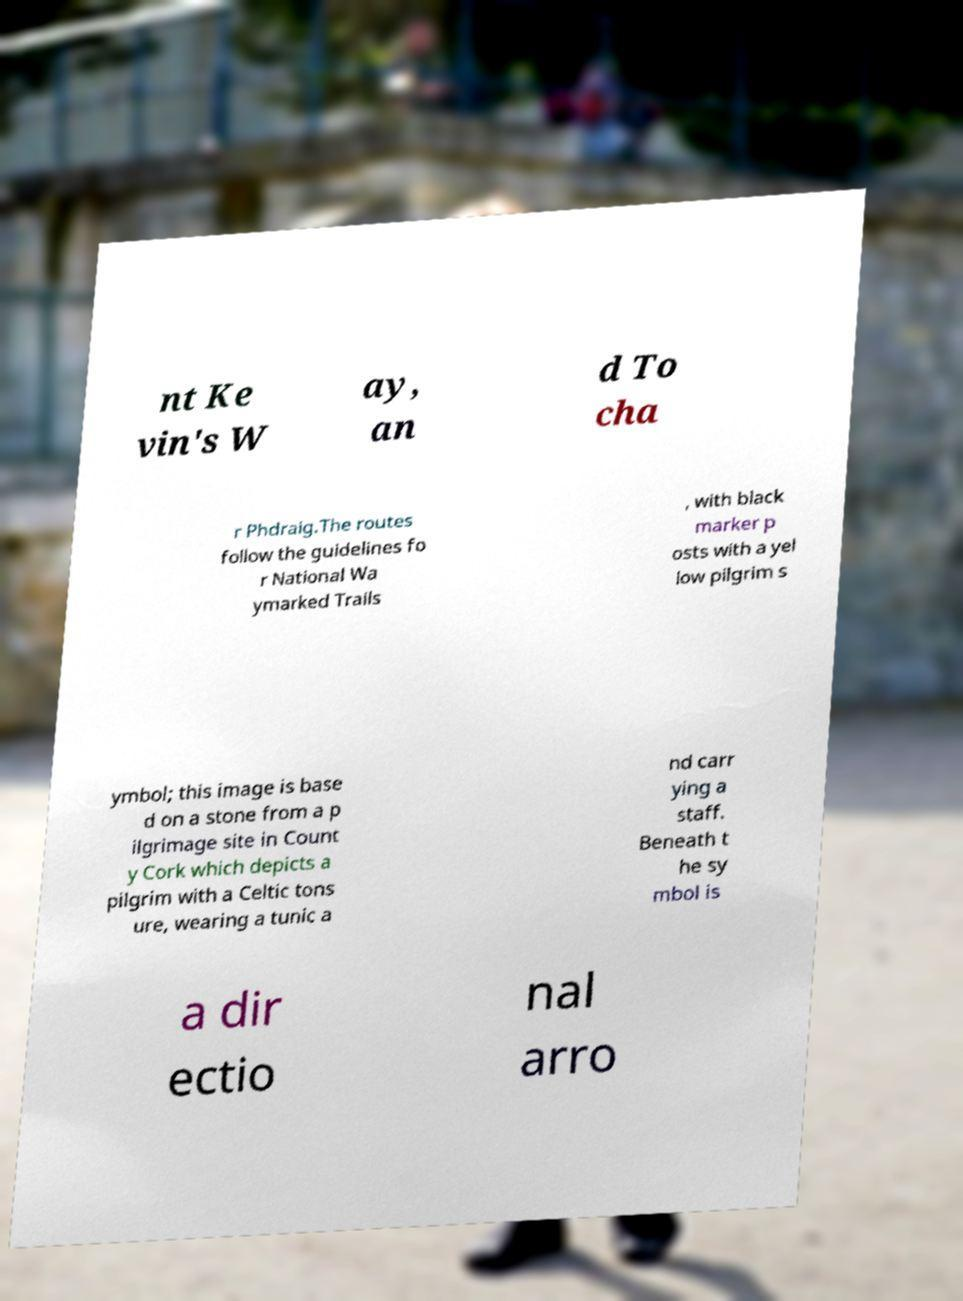For documentation purposes, I need the text within this image transcribed. Could you provide that? nt Ke vin's W ay, an d To cha r Phdraig.The routes follow the guidelines fo r National Wa ymarked Trails , with black marker p osts with a yel low pilgrim s ymbol; this image is base d on a stone from a p ilgrimage site in Count y Cork which depicts a pilgrim with a Celtic tons ure, wearing a tunic a nd carr ying a staff. Beneath t he sy mbol is a dir ectio nal arro 